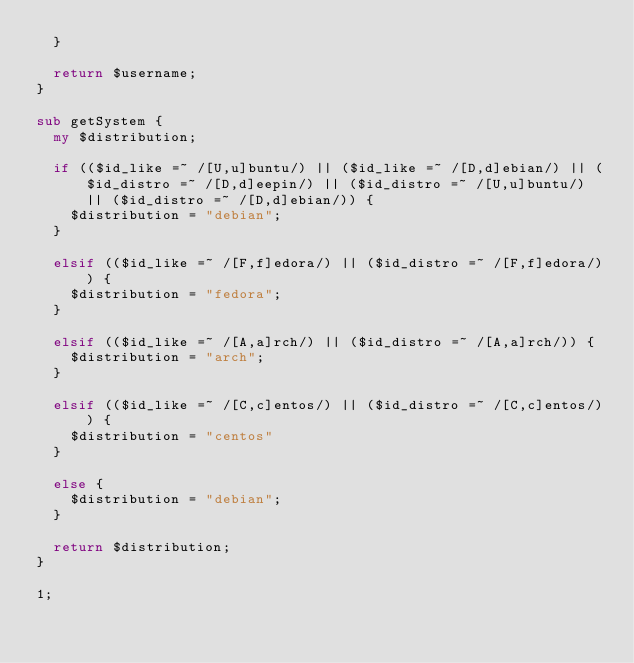Convert code to text. <code><loc_0><loc_0><loc_500><loc_500><_Perl_>	}

	return $username;
}

sub getSystem {
	my $distribution;

	if (($id_like =~ /[U,u]buntu/) || ($id_like =~ /[D,d]ebian/) || ($id_distro =~ /[D,d]eepin/) || ($id_distro =~ /[U,u]buntu/) || ($id_distro =~ /[D,d]ebian/)) {
		$distribution = "debian";
	}

	elsif (($id_like =~ /[F,f]edora/) || ($id_distro =~ /[F,f]edora/)) {
		$distribution = "fedora";
	}

	elsif (($id_like =~ /[A,a]rch/) || ($id_distro =~ /[A,a]rch/)) {
		$distribution = "arch";
	}

	elsif (($id_like =~ /[C,c]entos/) || ($id_distro =~ /[C,c]entos/)) {
		$distribution = "centos"
	}

	else {
		$distribution = "debian";
	}

	return $distribution;
}

1;
</code> 